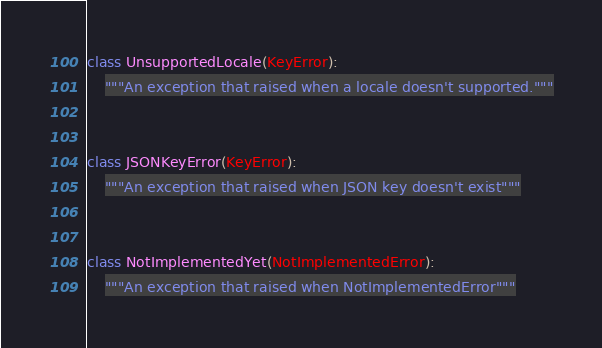Convert code to text. <code><loc_0><loc_0><loc_500><loc_500><_Python_>class UnsupportedLocale(KeyError):
    """An exception that raised when a locale doesn't supported."""


class JSONKeyError(KeyError):
    """An exception that raised when JSON key doesn't exist"""


class NotImplementedYet(NotImplementedError):
    """An exception that raised when NotImplementedError"""
</code> 